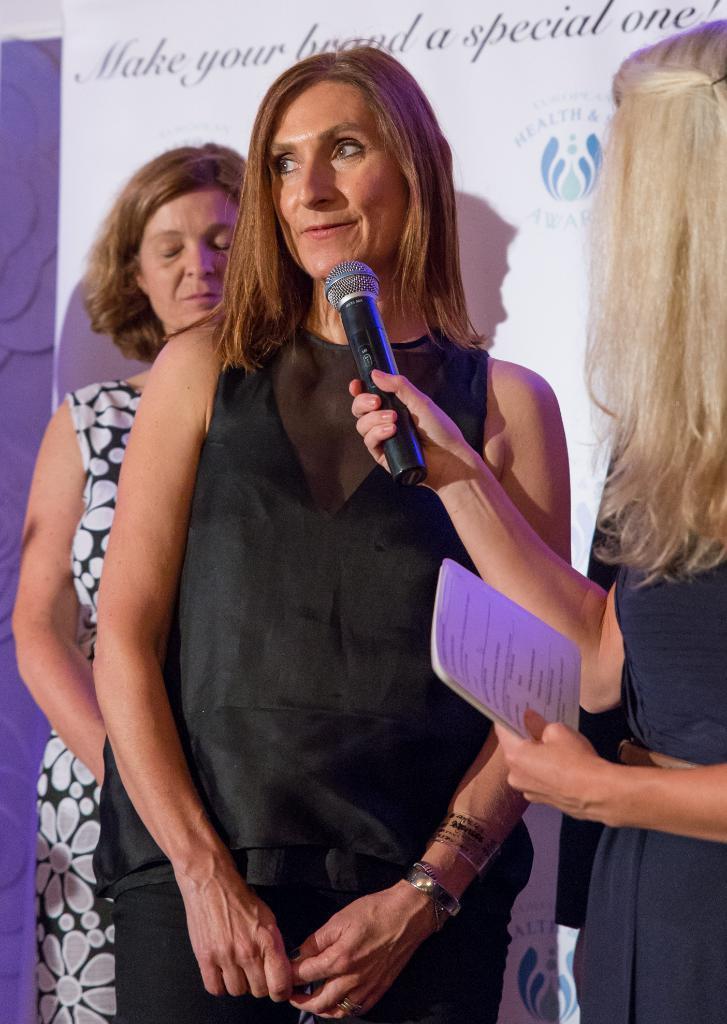How would you summarize this image in a sentence or two? In this image, In the middle there is a woman standing and in the right side there is a woman standing and she is holding a microphone which is in black color and in the background there is a white color wall and there is a old lady standing. 